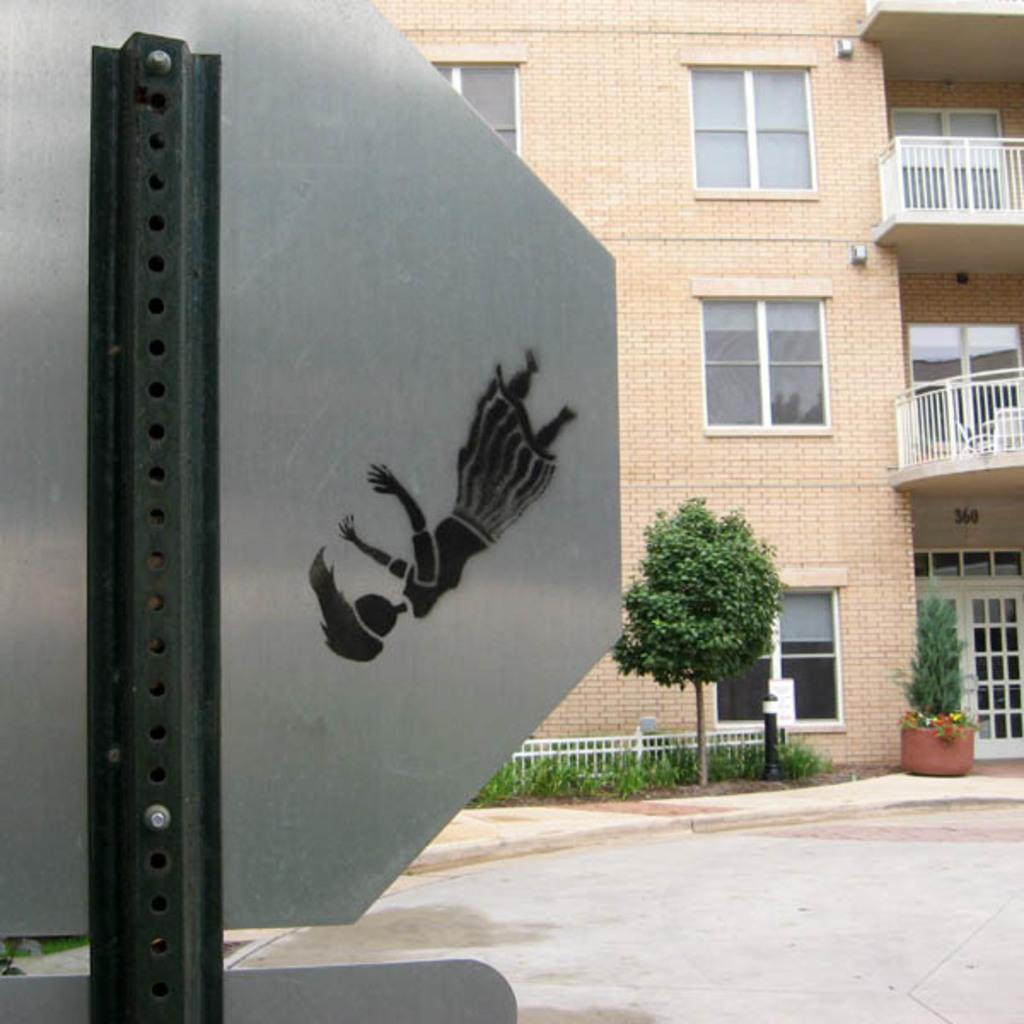What type of structure is present in the image? There is a building in the image. What natural element can be seen in the image? There is a tree in the image. What object is featured in the image that might be used for displaying information or advertisements? There is a board in the image. What type of outdoor space is visible in the image? There is a garden visible in the image. What type of oatmeal is being served in the garden in the image? There is no oatmeal present in the image; it features a building, a tree, a board, and a garden. What form does the tree take in the image? The tree is depicted in its natural form in the image, as a tree. 